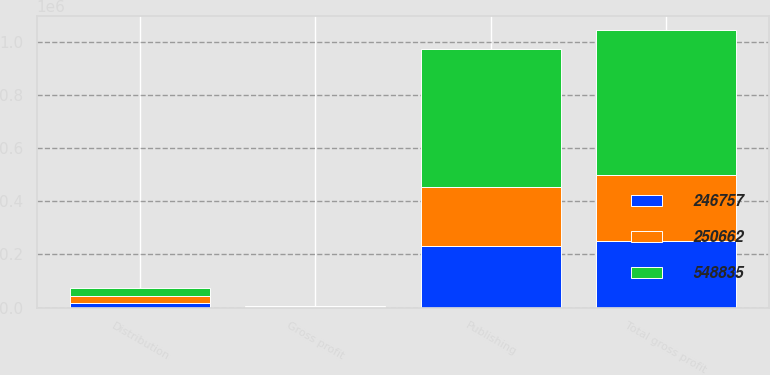<chart> <loc_0><loc_0><loc_500><loc_500><stacked_bar_chart><ecel><fcel>Gross profit<fcel>Publishing<fcel>Distribution<fcel>Total gross profit<nl><fcel>246757<fcel>2009<fcel>232990<fcel>17672<fcel>250662<nl><fcel>548835<fcel>2008<fcel>521615<fcel>27220<fcel>548835<nl><fcel>250662<fcel>2007<fcel>219651<fcel>27106<fcel>246757<nl></chart> 